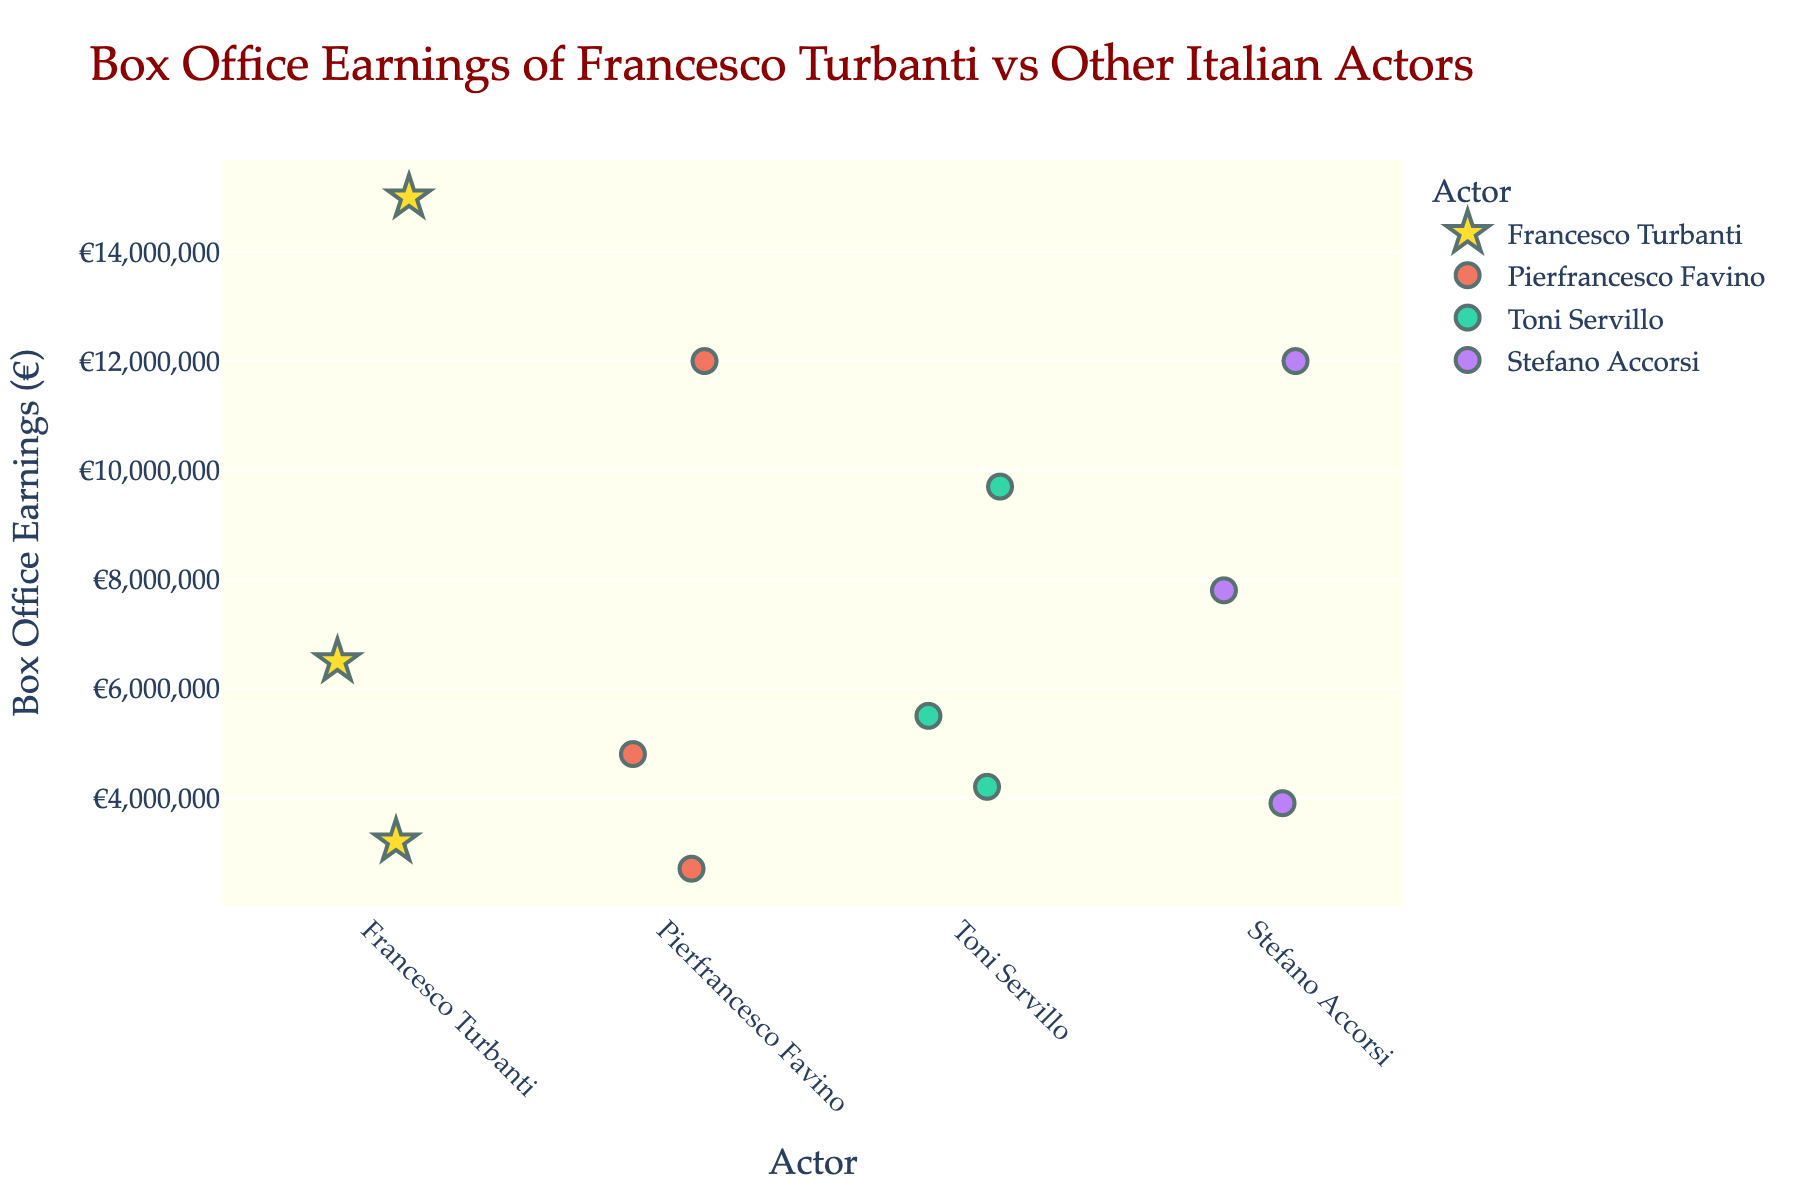Who is the actor with the highest box office earning in a single film? The highest mark on the y-axis represents the highest box office earning, which is associated with Francesco Turbanti for the film "Pinocchio".
Answer: Francesco Turbanti What is the total box office earnings of Francesco Turbanti's films? Adding box office earnings: €6,500,000 for "The First Beautiful Thing", €15,000,000 for "Pinocchio", and €3,200,000 for "The Perfect Crime" results in a total: €6,500,000 + €15,000,000 + €3,200,000 = €24,700,000.
Answer: €24,700,000 How many films by Pierfrancesco Favino are depicted? Checking the number of data points (stars) associated with Pierfrancesco Favino on the x-axis reveals three films ("The Traitor", "Padrenostro", and "The Last Kiss").
Answer: 3 Which actor has the lowest box office earnings for a film in the dataset? The film with the lowest box office earnings appears at the bottom of the y-axis for Pierfrancesco Favino's "Padrenostro" at €2,700,000.
Answer: Pierfrancesco Favino Is Francesco Turbanti's median box office earning higher than Toni Servillo's highest box office earning? Francesco Turbanti's earnings are (€6,500,000, €3,200,000, and €15,000,000) with a median of €6,500,000. Toni Servillo's highest is €9,700,000 for "The Great Beauty". Since €6,500,000 < €9,700,000, it is not higher.
Answer: No Which actor made the film "Romanzo Criminale"? Identifying the hover information for the film title "Romanzo Criminale" tells us Stefano Accorsi is the actor.
Answer: Stefano Accorsi How many films by Stefano Accorsi have box office earnings higher than €6,000,000? Checking Stefano Accorsi's films, only "The Last Kiss" (€12,000,000) and "Romanzo Criminale" (€7,800,000) have a box office above €6,000,000.
Answer: 2 Which actor has the most films in the dataset? By counting the number of data points for each actor along the x-axis, it is evident that Toni Servillo and Stefano Accorsi both have three films each.
Answer: Tie between Toni Servillo and Stefano Accorsi Are there any films with earnings exactly at €5,500,000? Checking the y-axis values and the associated films, it shows Toni Servillo's "Il Divo" has earned exactly €5,500,000.
Answer: Yes Which actor's films show the widest range of box office earnings? Calculating the range for each actor - Francesco Turbanti (€15,000,000 - €3,200,000 = €11,800,000), Pierfrancesco Favino (€12,000,000 - €2,700,000 = €9,300,000), Toni Servillo (€9,700,000 - €4,200,000 = €5,500,000), Stefano Accorsi (€12,000,000 - €3,900,000 = €8,100,000): Widest range is Francesco Turbanti's.
Answer: Francesco Turbanti 